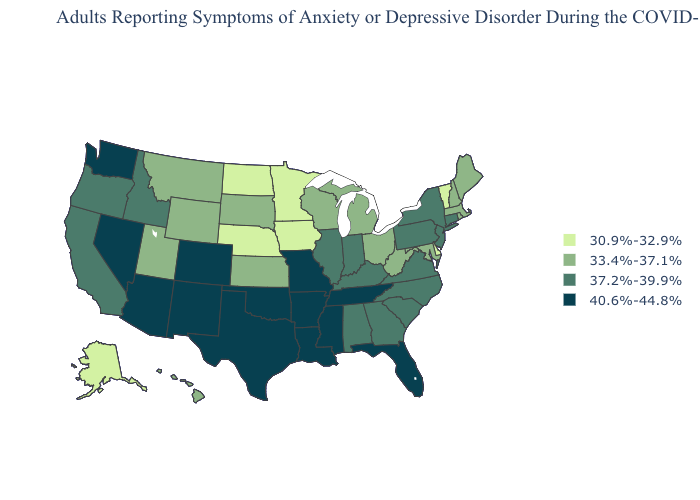Among the states that border Kansas , does Colorado have the lowest value?
Be succinct. No. Does Delaware have a higher value than Nevada?
Concise answer only. No. Does Arkansas have the same value as New Mexico?
Keep it brief. Yes. Is the legend a continuous bar?
Give a very brief answer. No. Name the states that have a value in the range 37.2%-39.9%?
Keep it brief. Alabama, California, Connecticut, Georgia, Idaho, Illinois, Indiana, Kentucky, New Jersey, New York, North Carolina, Oregon, Pennsylvania, South Carolina, Virginia. How many symbols are there in the legend?
Answer briefly. 4. What is the highest value in the Northeast ?
Give a very brief answer. 37.2%-39.9%. Among the states that border New Mexico , which have the highest value?
Write a very short answer. Arizona, Colorado, Oklahoma, Texas. Does Tennessee have the lowest value in the South?
Short answer required. No. What is the highest value in the West ?
Write a very short answer. 40.6%-44.8%. What is the lowest value in the South?
Be succinct. 30.9%-32.9%. Name the states that have a value in the range 40.6%-44.8%?
Quick response, please. Arizona, Arkansas, Colorado, Florida, Louisiana, Mississippi, Missouri, Nevada, New Mexico, Oklahoma, Tennessee, Texas, Washington. Does Arizona have the highest value in the USA?
Be succinct. Yes. What is the value of South Dakota?
Answer briefly. 33.4%-37.1%. 